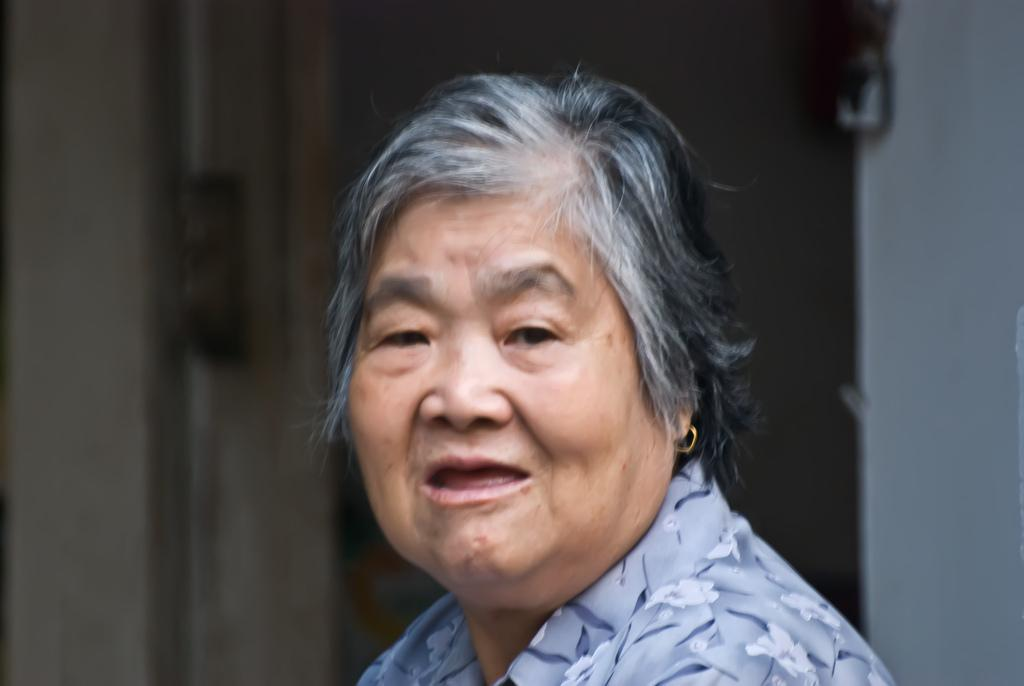Who is the main subject in the image? There is a woman in the image. What is behind the woman in the image? There is a wall behind the woman in the image. How many cents are visible on the woman's hand in the image? There are no cents visible on the woman's hand in the image. What word is written on the wall behind the woman in the image? There is no word written on the wall behind the woman in the image. 